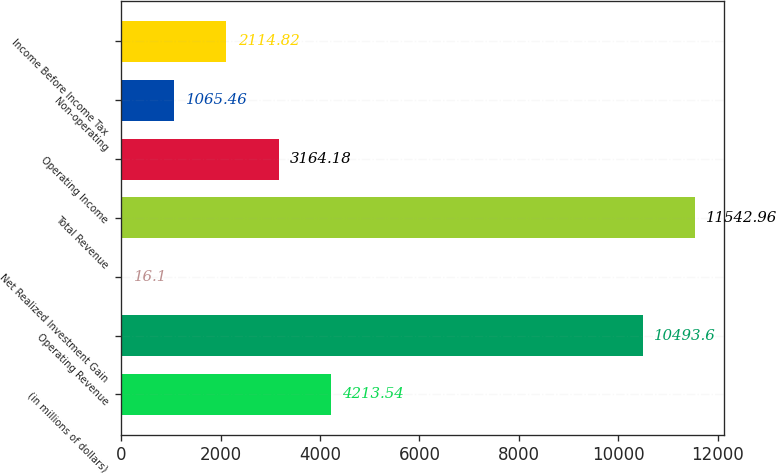<chart> <loc_0><loc_0><loc_500><loc_500><bar_chart><fcel>(in millions of dollars)<fcel>Operating Revenue<fcel>Net Realized Investment Gain<fcel>Total Revenue<fcel>Operating Income<fcel>Non-operating<fcel>Income Before Income Tax<nl><fcel>4213.54<fcel>10493.6<fcel>16.1<fcel>11543<fcel>3164.18<fcel>1065.46<fcel>2114.82<nl></chart> 